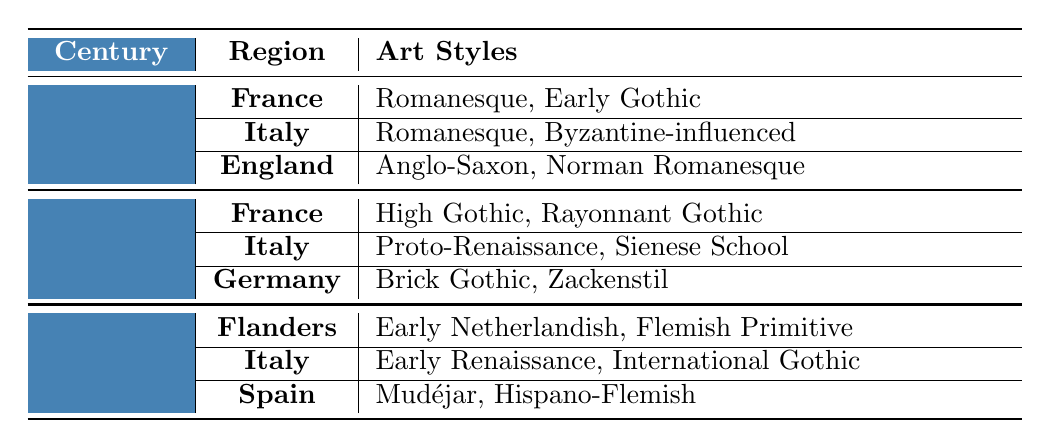What art styles are associated with England in the 11th-12th century? The table specifies that for the 11th-12th century, England has two associated art styles: Anglo-Saxon and Norman Romanesque.
Answer: Anglo-Saxon, Norman Romanesque Which region is associated with High Gothic art style? According to the table, the High Gothic art style is associated with France in the 13th-14th century.
Answer: France Is the Proto-Renaissance style represented in the 15th century? The table shows that Proto-Renaissance is listed under the 13th-14th century, thus it is not represented in the 15th century.
Answer: No How many distinct art styles are listed for Italy across all centuries? Italy has Romanesque and Byzantine-influenced in the 11th-12th century, Proto-Renaissance and Sienese School in the 13th-14th century, and Early Renaissance and International Gothic in the 15th century. This totals 6 distinct styles.
Answer: 6 Which region features the Mudéjar art style, and in what century? The table indicates that the Mudéjar art style is associated with Spain in the 15th century.
Answer: Spain, 15th century What is the difference in the number of art styles listed for France in the 11th-12th century compared to the 13th-14th century? France has 2 art styles (Romanesque, Early Gothic) in the 11th-12th century and 2 art styles (High Gothic, Rayonnant Gothic) in the 13th-14th century. The difference is 2 - 2 = 0.
Answer: 0 Are there any regions that feature both Romanesque and Gothic styles? Yes, the table shows that Italy has Romanesque styles in the 11th-12th century and later has styles that transition into Gothic such as Early Renaissance in the 15th century.
Answer: Yes Identify the regions with art styles mentioned in the 15th century. The 15th century features art styles from three regions: Flanders with Early Netherlandish and Flemish Primitive, Italy with Early Renaissance and International Gothic, and Spain with Mudéjar and Hispano-Flemish.
Answer: Flanders, Italy, Spain Among the regions listed, which was the first to develop Norman Romanesque styles? The table indicates that Norman Romanesque style is associated with England, which occurs in the 11th-12th century. Therefore, England was the first to develop it.
Answer: England What can you conclude about the evolution of art styles from the 11th-12th century to the 15th century? The data shows a progression from styles such as Romanesque and Byzantine-influenced in the earlier centuries to more complex styles like Early Renaissance and International Gothic by the 15th century, suggesting a shift towards more nuanced artistic expression.
Answer: A progression towards more complex styles 